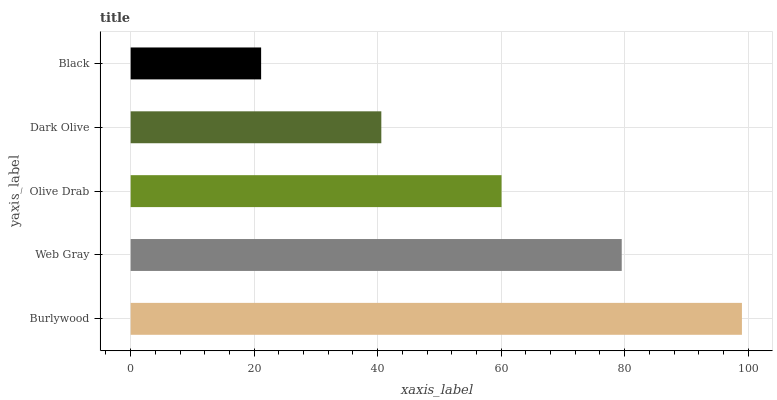Is Black the minimum?
Answer yes or no. Yes. Is Burlywood the maximum?
Answer yes or no. Yes. Is Web Gray the minimum?
Answer yes or no. No. Is Web Gray the maximum?
Answer yes or no. No. Is Burlywood greater than Web Gray?
Answer yes or no. Yes. Is Web Gray less than Burlywood?
Answer yes or no. Yes. Is Web Gray greater than Burlywood?
Answer yes or no. No. Is Burlywood less than Web Gray?
Answer yes or no. No. Is Olive Drab the high median?
Answer yes or no. Yes. Is Olive Drab the low median?
Answer yes or no. Yes. Is Black the high median?
Answer yes or no. No. Is Dark Olive the low median?
Answer yes or no. No. 